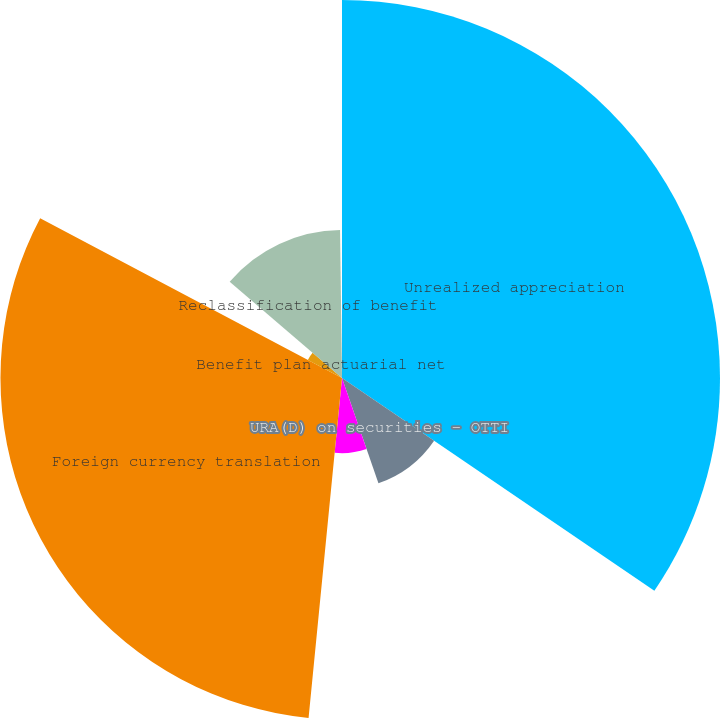Convert chart. <chart><loc_0><loc_0><loc_500><loc_500><pie_chart><fcel>Unrealized appreciation<fcel>URA(D) on securities - OTTI<fcel>Reclassification of net<fcel>Foreign currency translation<fcel>Benefit plan actuarial net<fcel>Reclassification of benefit<fcel>Total other comprehensive<nl><fcel>34.52%<fcel>10.18%<fcel>6.86%<fcel>31.19%<fcel>3.53%<fcel>13.51%<fcel>0.21%<nl></chart> 